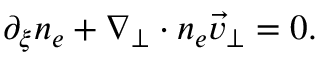Convert formula to latex. <formula><loc_0><loc_0><loc_500><loc_500>\begin{array} { r } { \partial _ { \xi } n _ { e } + \nabla _ { \perp } \cdot n _ { e } \vec { v } _ { \perp } = 0 . } \end{array}</formula> 